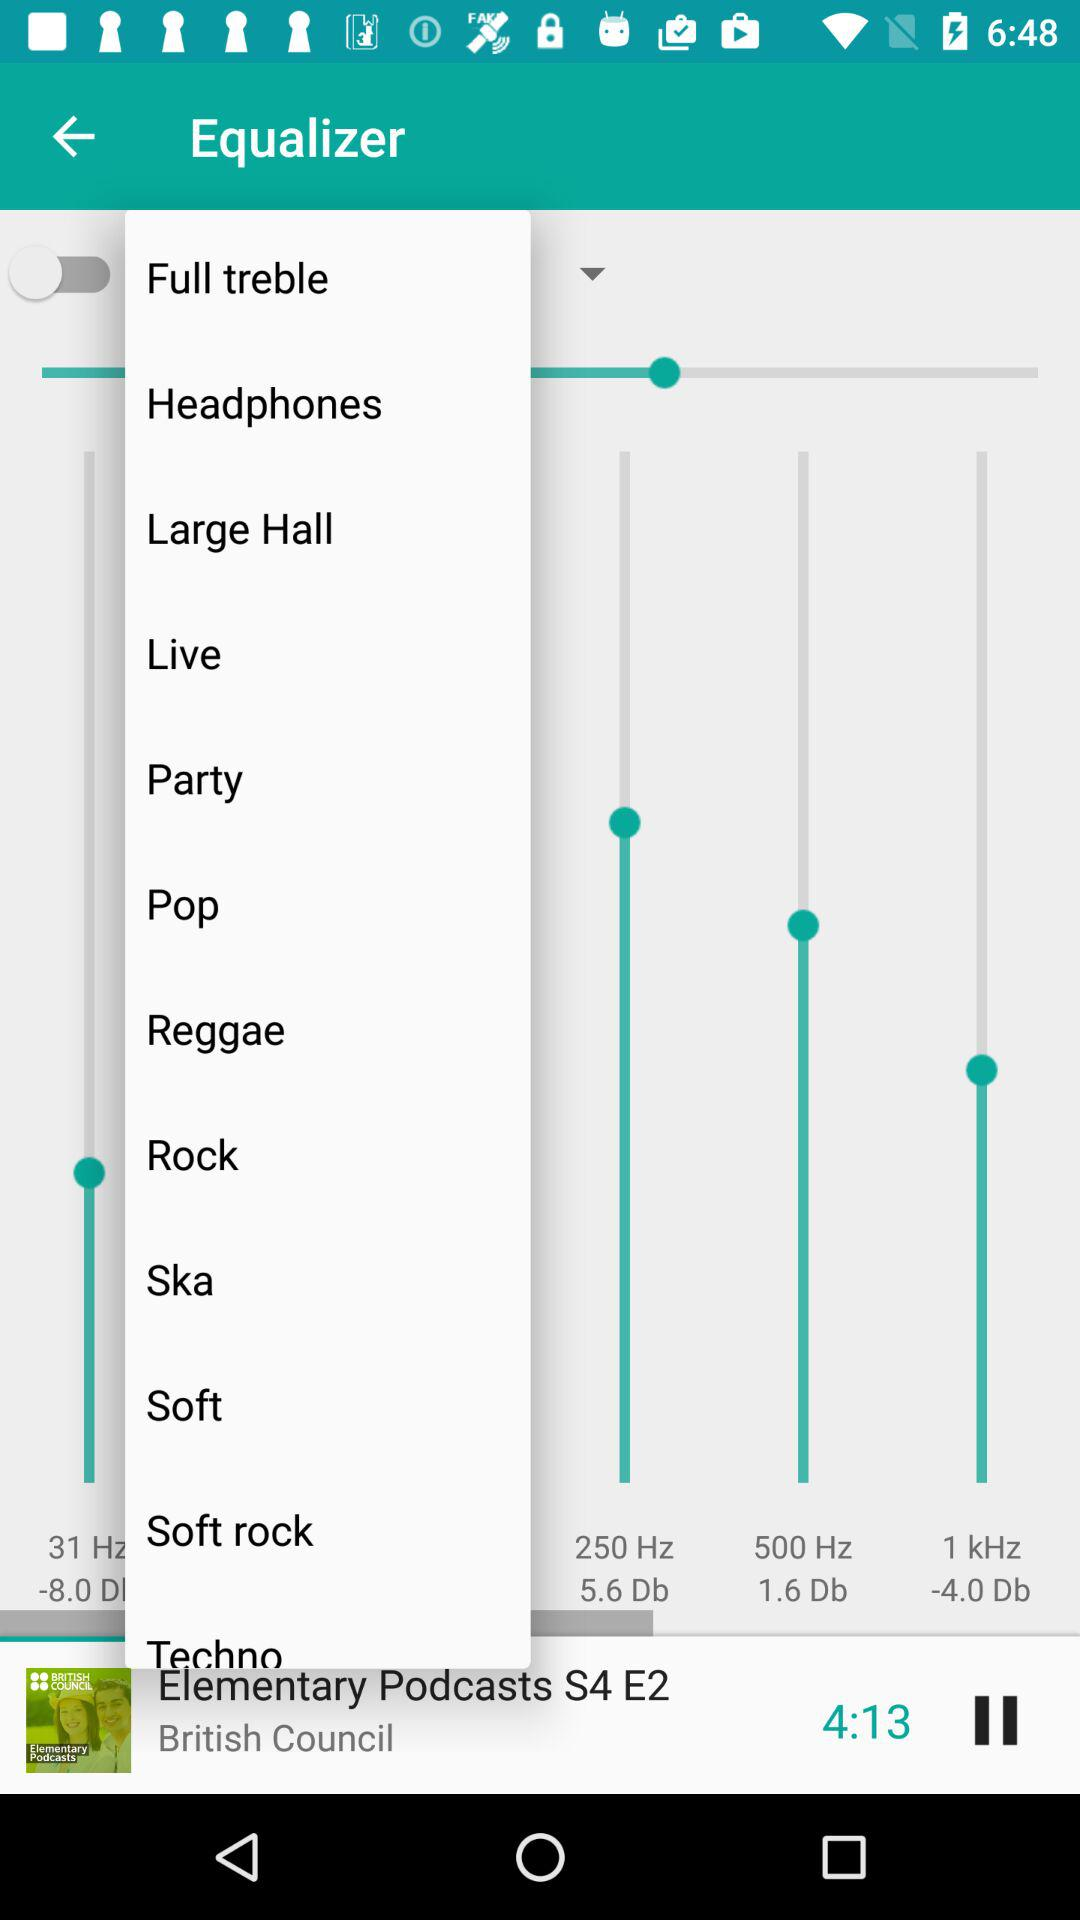What is the duration of the song? The duration of the song is 4 minute and 13 seconds. 